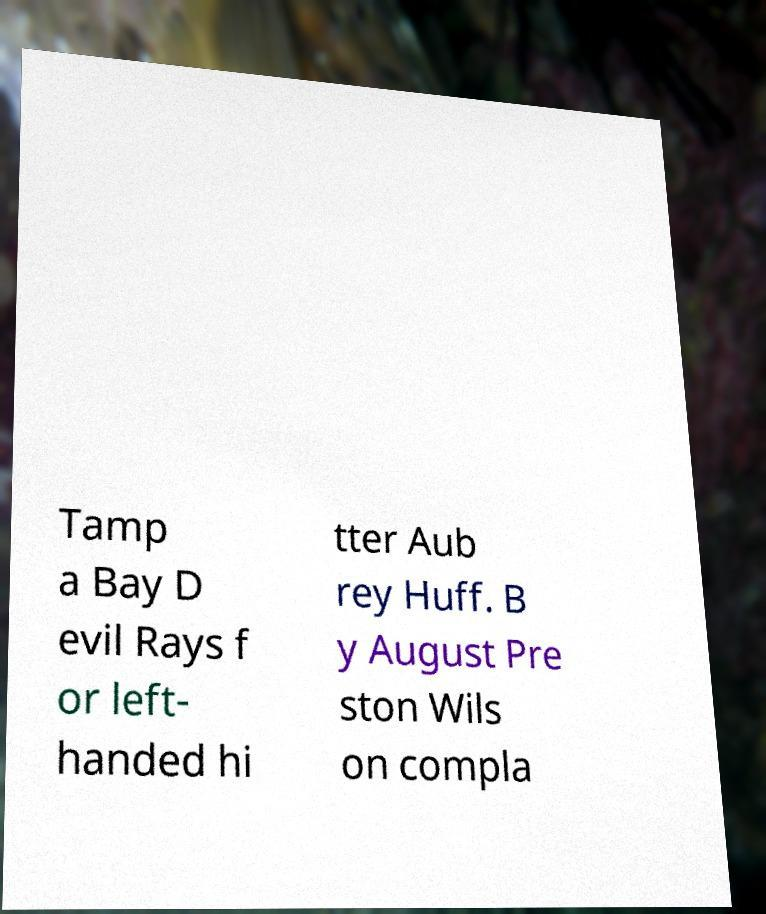Could you assist in decoding the text presented in this image and type it out clearly? Tamp a Bay D evil Rays f or left- handed hi tter Aub rey Huff. B y August Pre ston Wils on compla 